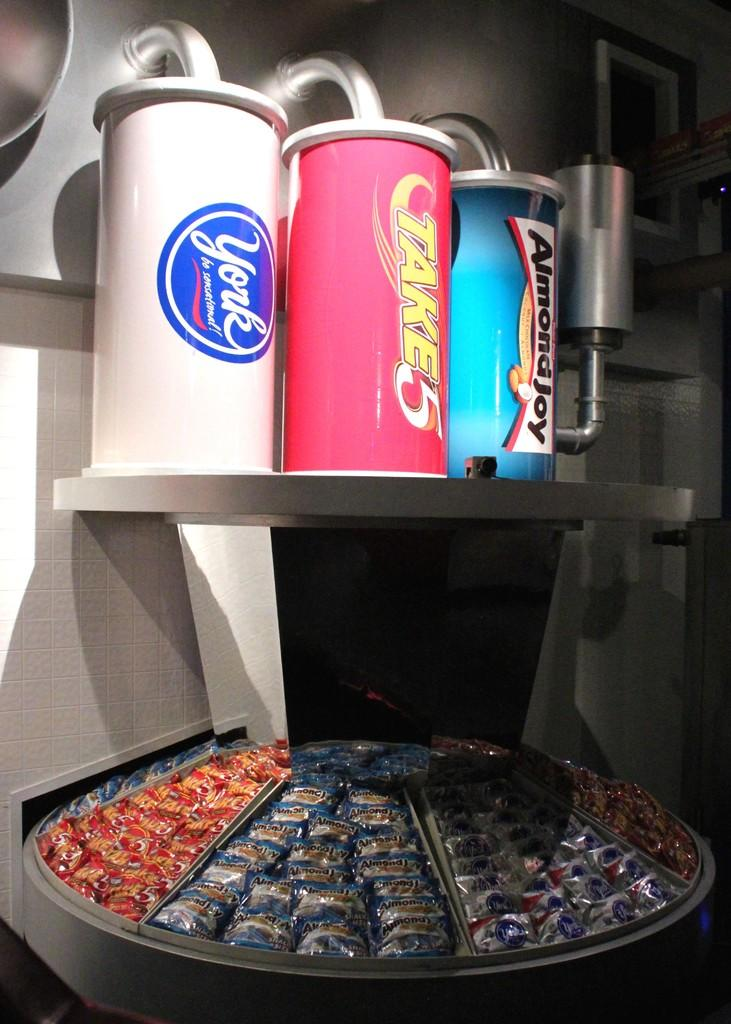Provide a one-sentence caption for the provided image. A lot of candy bars including Almondjoy and Take5. 